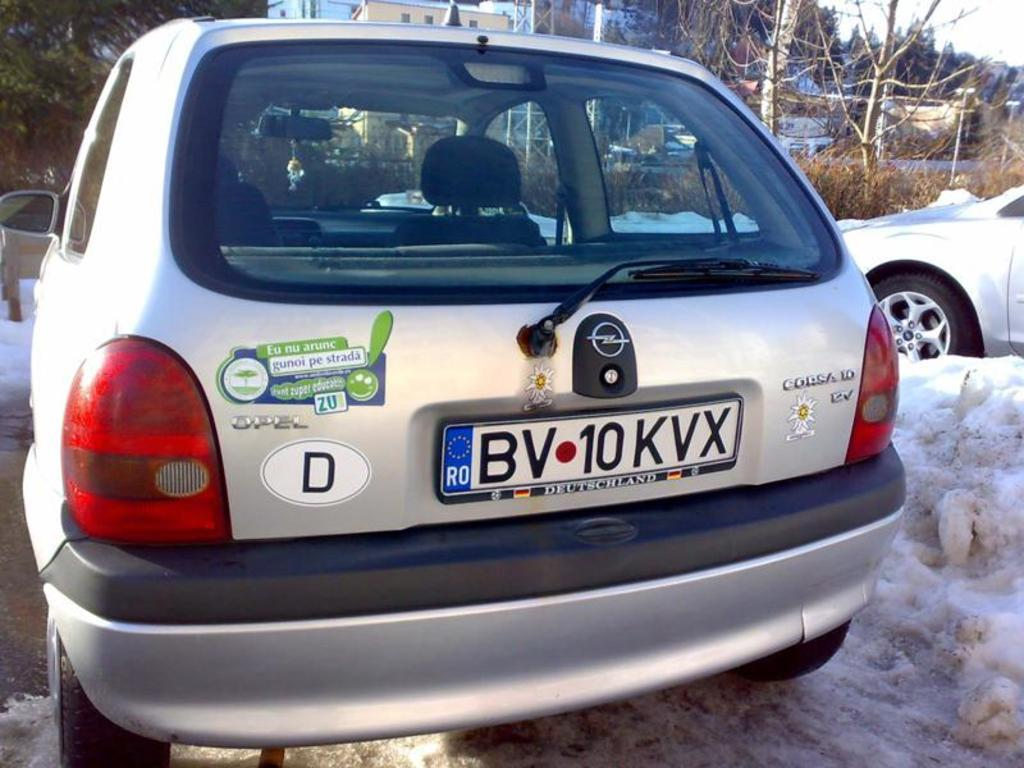Provide a one-sentence caption for the provided image. a opel corsica car with a dutch license. 